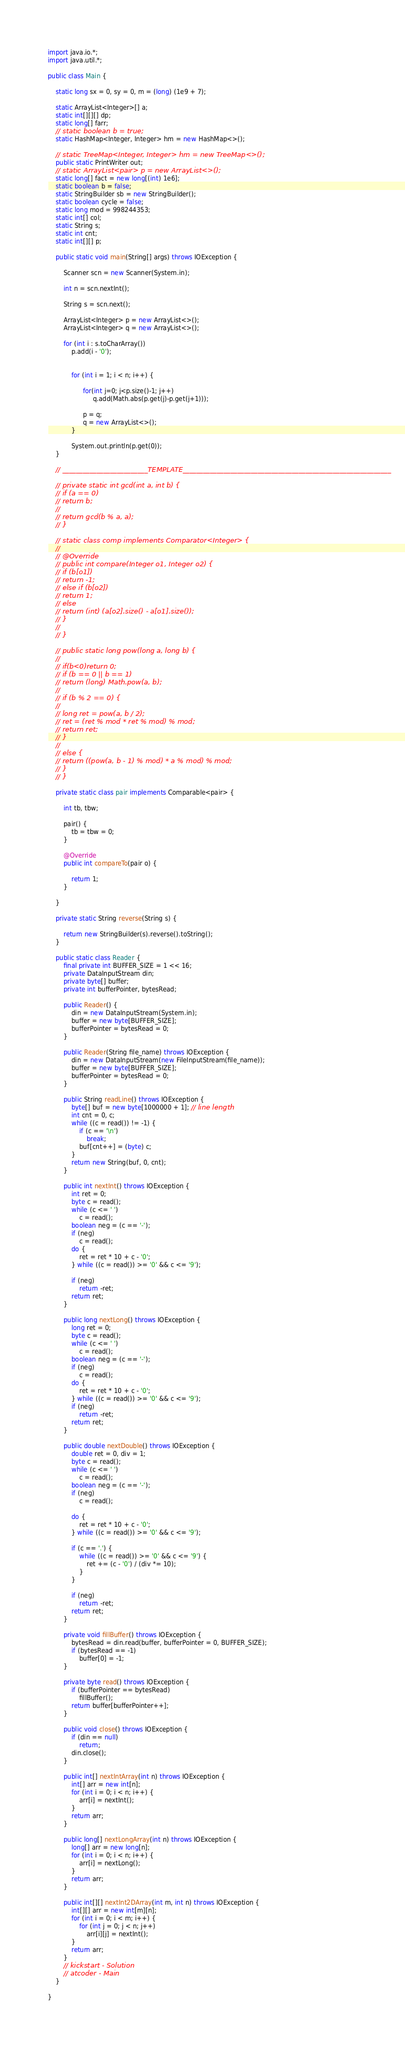Convert code to text. <code><loc_0><loc_0><loc_500><loc_500><_Java_>
import java.io.*;
import java.util.*;

public class Main {

	static long sx = 0, sy = 0, m = (long) (1e9 + 7);

	static ArrayList<Integer>[] a;
	static int[][][] dp;
	static long[] farr;
	// static boolean b = true;
	static HashMap<Integer, Integer> hm = new HashMap<>();

	// static TreeMap<Integer, Integer> hm = new TreeMap<>();
	public static PrintWriter out;
	// static ArrayList<pair> p = new ArrayList<>();
	static long[] fact = new long[(int) 1e6];
	static boolean b = false;
	static StringBuilder sb = new StringBuilder();
	static boolean cycle = false;
	static long mod = 998244353;
	static int[] col;
	static String s;
	static int cnt;
	static int[][] p;

	public static void main(String[] args) throws IOException {

		Scanner scn = new Scanner(System.in);

		int n = scn.nextInt();

		String s = scn.next();

		ArrayList<Integer> p = new ArrayList<>();
		ArrayList<Integer> q = new ArrayList<>();

		for (int i : s.toCharArray())
			p.add(i - '0');

			
			for (int i = 1; i < n; i++) {
                  
				  for(int j=0; j<p.size()-1; j++)
					   q.add(Math.abs(p.get(j)-p.get(j+1)));
				  
				  p = q;
				  q = new ArrayList<>();
			}
			
			System.out.println(p.get(0));
	}

	// _________________________TEMPLATE_____________________________________________________________

	// private static int gcd(int a, int b) {
	// if (a == 0)
	// return b;
	//
	// return gcd(b % a, a);
	// }

	// static class comp implements Comparator<Integer> {
	//
	// @Override
	// public int compare(Integer o1, Integer o2) {
	// if (b[o1])
	// return -1;
	// else if (b[o2])
	// return 1;
	// else
	// return (int) (a[o2].size() - a[o1].size());
	// }
	//
	// }

	// public static long pow(long a, long b) {
	//
	// if(b<0)return 0;
	// if (b == 0 || b == 1)
	// return (long) Math.pow(a, b);
	//
	// if (b % 2 == 0) {
	//
	// long ret = pow(a, b / 2);
	// ret = (ret % mod * ret % mod) % mod;
	// return ret;
	// }
	//
	// else {
	// return ((pow(a, b - 1) % mod) * a % mod) % mod;
	// }
	// }

	private static class pair implements Comparable<pair> {

		int tb, tbw;

		pair() {
			tb = tbw = 0;
		}

		@Override
		public int compareTo(pair o) {

			return 1;
		}

	}

	private static String reverse(String s) {

		return new StringBuilder(s).reverse().toString();
	}

	public static class Reader {
		final private int BUFFER_SIZE = 1 << 16;
		private DataInputStream din;
		private byte[] buffer;
		private int bufferPointer, bytesRead;

		public Reader() {
			din = new DataInputStream(System.in);
			buffer = new byte[BUFFER_SIZE];
			bufferPointer = bytesRead = 0;
		}

		public Reader(String file_name) throws IOException {
			din = new DataInputStream(new FileInputStream(file_name));
			buffer = new byte[BUFFER_SIZE];
			bufferPointer = bytesRead = 0;
		}

		public String readLine() throws IOException {
			byte[] buf = new byte[1000000 + 1]; // line length
			int cnt = 0, c;
			while ((c = read()) != -1) {
				if (c == '\n')
					break;
				buf[cnt++] = (byte) c;
			}
			return new String(buf, 0, cnt);
		}

		public int nextInt() throws IOException {
			int ret = 0;
			byte c = read();
			while (c <= ' ')
				c = read();
			boolean neg = (c == '-');
			if (neg)
				c = read();
			do {
				ret = ret * 10 + c - '0';
			} while ((c = read()) >= '0' && c <= '9');

			if (neg)
				return -ret;
			return ret;
		}

		public long nextLong() throws IOException {
			long ret = 0;
			byte c = read();
			while (c <= ' ')
				c = read();
			boolean neg = (c == '-');
			if (neg)
				c = read();
			do {
				ret = ret * 10 + c - '0';
			} while ((c = read()) >= '0' && c <= '9');
			if (neg)
				return -ret;
			return ret;
		}

		public double nextDouble() throws IOException {
			double ret = 0, div = 1;
			byte c = read();
			while (c <= ' ')
				c = read();
			boolean neg = (c == '-');
			if (neg)
				c = read();

			do {
				ret = ret * 10 + c - '0';
			} while ((c = read()) >= '0' && c <= '9');

			if (c == '.') {
				while ((c = read()) >= '0' && c <= '9') {
					ret += (c - '0') / (div *= 10);
				}
			}

			if (neg)
				return -ret;
			return ret;
		}

		private void fillBuffer() throws IOException {
			bytesRead = din.read(buffer, bufferPointer = 0, BUFFER_SIZE);
			if (bytesRead == -1)
				buffer[0] = -1;
		}

		private byte read() throws IOException {
			if (bufferPointer == bytesRead)
				fillBuffer();
			return buffer[bufferPointer++];
		}

		public void close() throws IOException {
			if (din == null)
				return;
			din.close();
		}

		public int[] nextIntArray(int n) throws IOException {
			int[] arr = new int[n];
			for (int i = 0; i < n; i++) {
				arr[i] = nextInt();
			}
			return arr;
		}

		public long[] nextLongArray(int n) throws IOException {
			long[] arr = new long[n];
			for (int i = 0; i < n; i++) {
				arr[i] = nextLong();
			}
			return arr;
		}

		public int[][] nextInt2DArray(int m, int n) throws IOException {
			int[][] arr = new int[m][n];
			for (int i = 0; i < m; i++) {
				for (int j = 0; j < n; j++)
					arr[i][j] = nextInt();
			}
			return arr;
		}
		// kickstart - Solution
		// atcoder - Main
	}

}
</code> 